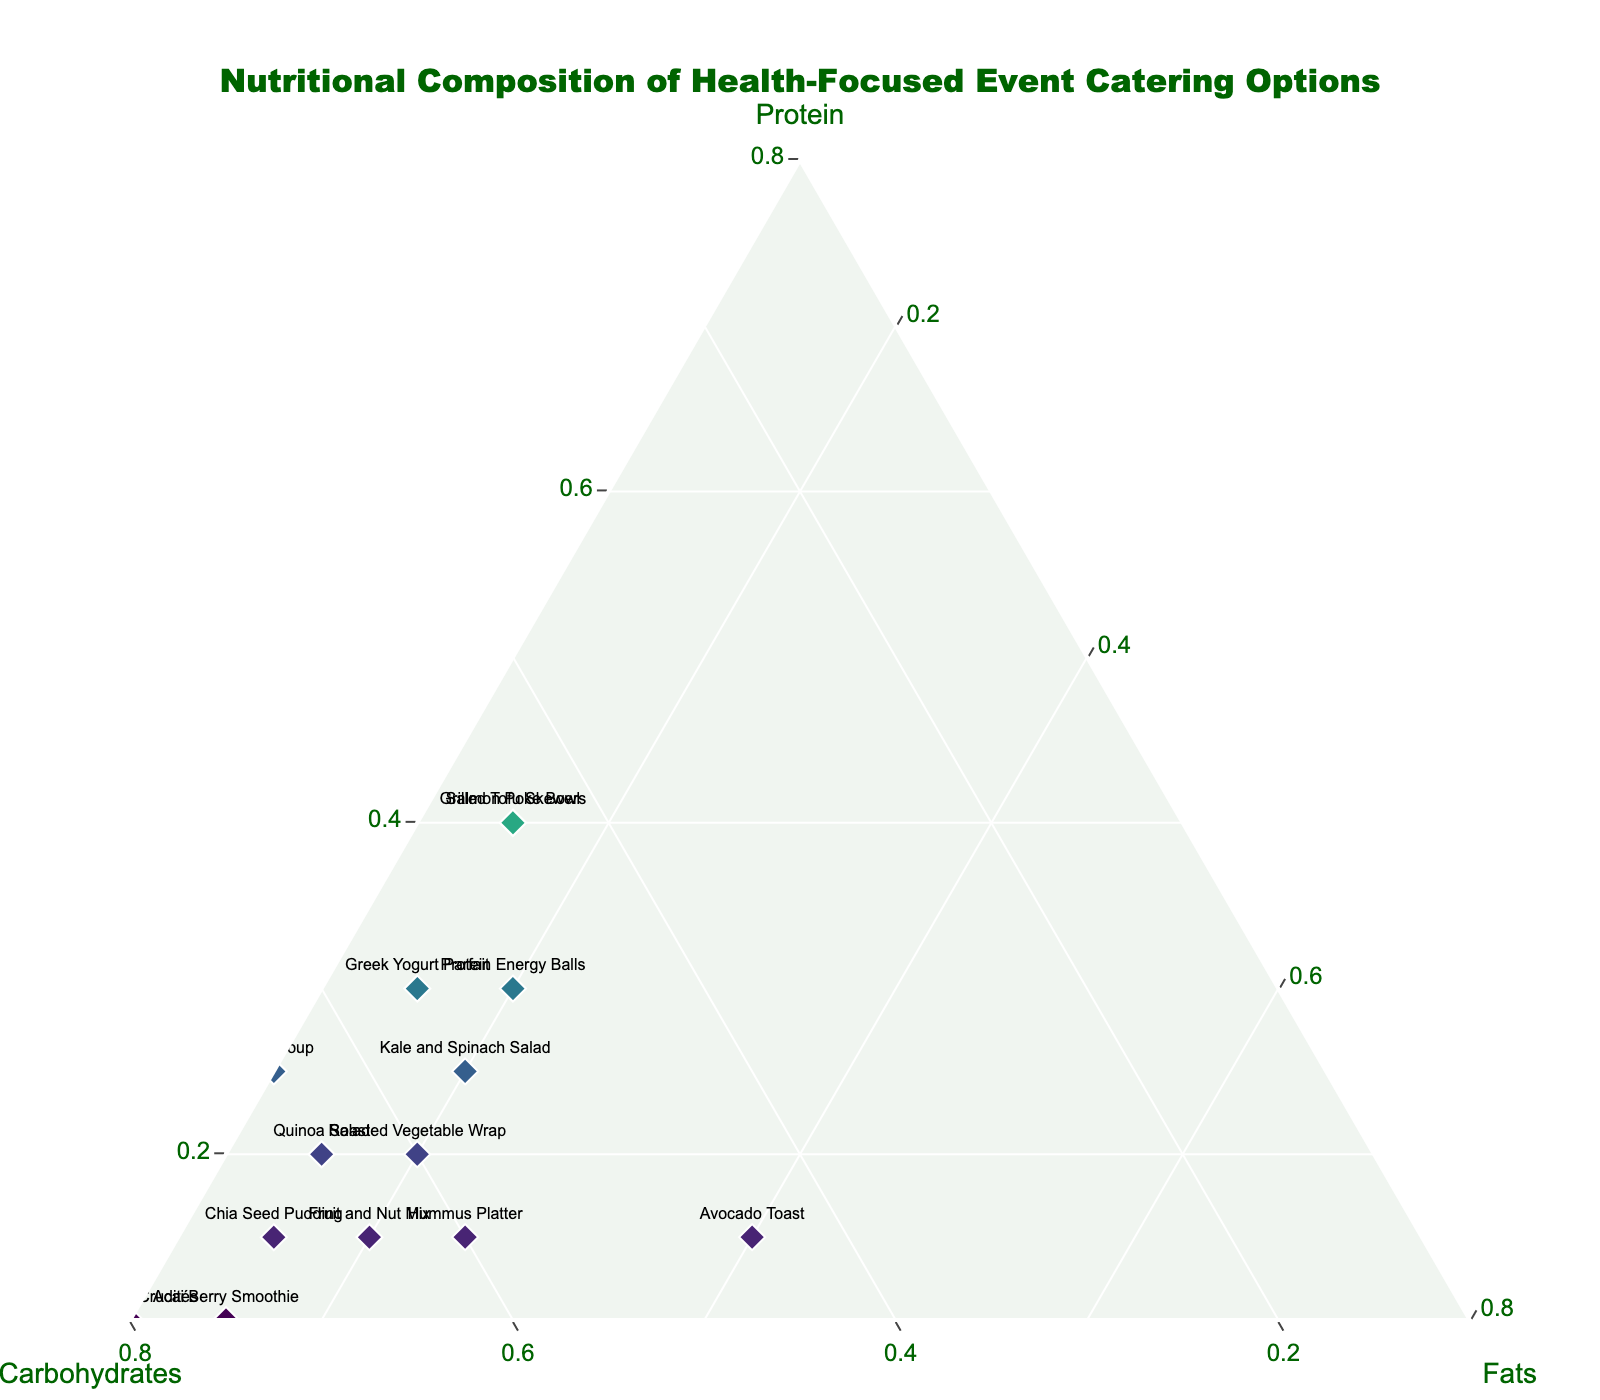What is the title of the ternary plot? The title of the plot is located at the top of the figure.
Answer: Nutritional Composition of Health-Focused Event Catering Options How many data points, representing different food items, are displayed in the plot? By counting the labels of food items on the ternary plot, you can determine the number of data points.
Answer: 15 Which food item has the highest proportion of protein? Look at the position of food items along the Protein axis. The one closest to the Protein vertex has the highest proportion of protein.
Answer: Grilled Chicken Breast Which food item has approximately equal proportions of protein, carbohydrates, and fats? Locate the food item that is nearest to the center of the ternary plot.
Answer: Grilled Tofu Skewers Which food item has more carbohydrates: Acai Berry Smoothie or Greek Yogurt Parfait? Compare the positions of 'Acai Berry Smoothie' and 'Greek Yogurt Parfait' along the Carbohydrates axis. The one closer to the Carbohydrates vertex has more carbohydrates.
Answer: Acai Berry Smoothie Which food item contains the least amount of fats? Find the food item that is closest to the Fats axis and farthest from the Fats vertex.
Answer: Vegetable Crudités Calculate the average percentage composition of carbohydrates for Quinoa Salad, Roasted Vegetable Wrap, and Fruit and Nut Mix. First, calculate the percentage compositions of carbohydrates for these three items from their positions: Quinoa Salad (65%), Roasted Vegetable Wrap (60%), Fruit and Nut Mix (65%). Then find the average: (65+60+65)/3 = 63.33%.
Answer: 63.33% Does the Salmon Poke Bowl have a higher proportion of protein or carbohydrates? Look at the Salmon Poke Bowl's position relative to the Protein and Carbohydrates axes.
Answer: Protein Compare the food items 'Kale and Spinach Salad' and 'Lentil Soup'. Which one has a higher proportion of fats? Examine the positions of 'Kale and Spinach Salad' and 'Lentil Soup' relative to the Fats axis.
Answer: Kale and Spinach Salad Identify the food items that have exactly 15% fats. Check the data points that align with 15% on the Fats axis.
Answer: Quinoa Salad, Greek Yogurt Parfait, Salmon Poke Bowl, Chia Seed Pudding, Grilled Tofu Skewers 